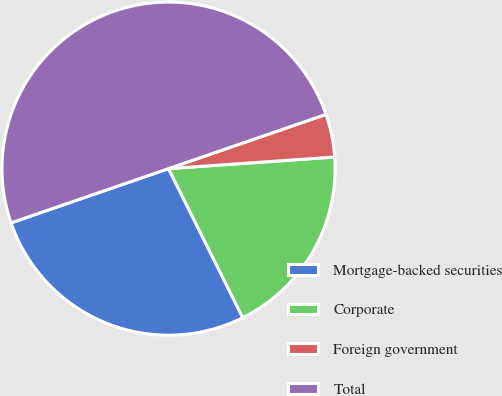Convert chart to OTSL. <chart><loc_0><loc_0><loc_500><loc_500><pie_chart><fcel>Mortgage-backed securities<fcel>Corporate<fcel>Foreign government<fcel>Total<nl><fcel>27.08%<fcel>18.75%<fcel>4.17%<fcel>50.0%<nl></chart> 